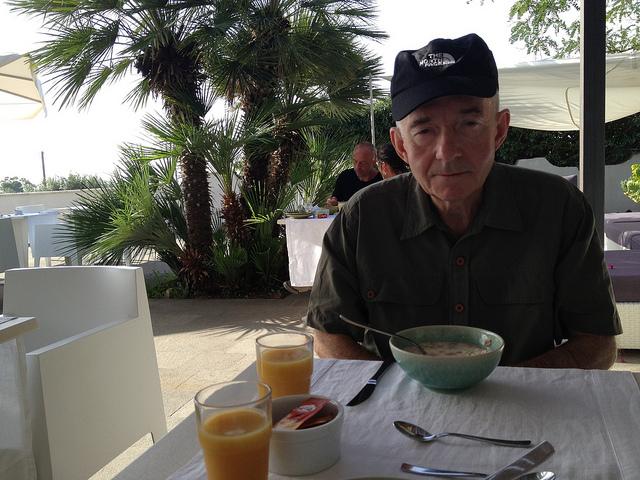Is the table set for one person or two people?
Keep it brief. 2. What is in the bowl in front of the man?
Answer briefly. Cereal. Is there any silverware?
Concise answer only. Yes. Was this picture taken in Maine?
Concise answer only. No. 